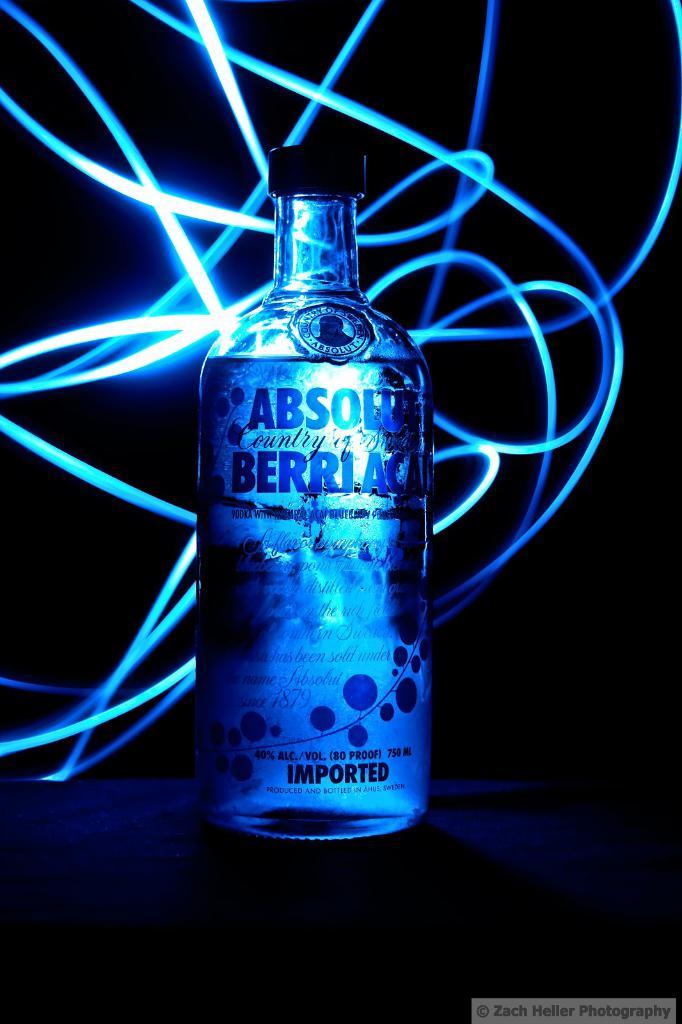Is absolute a vodka?
Give a very brief answer. Yes. 